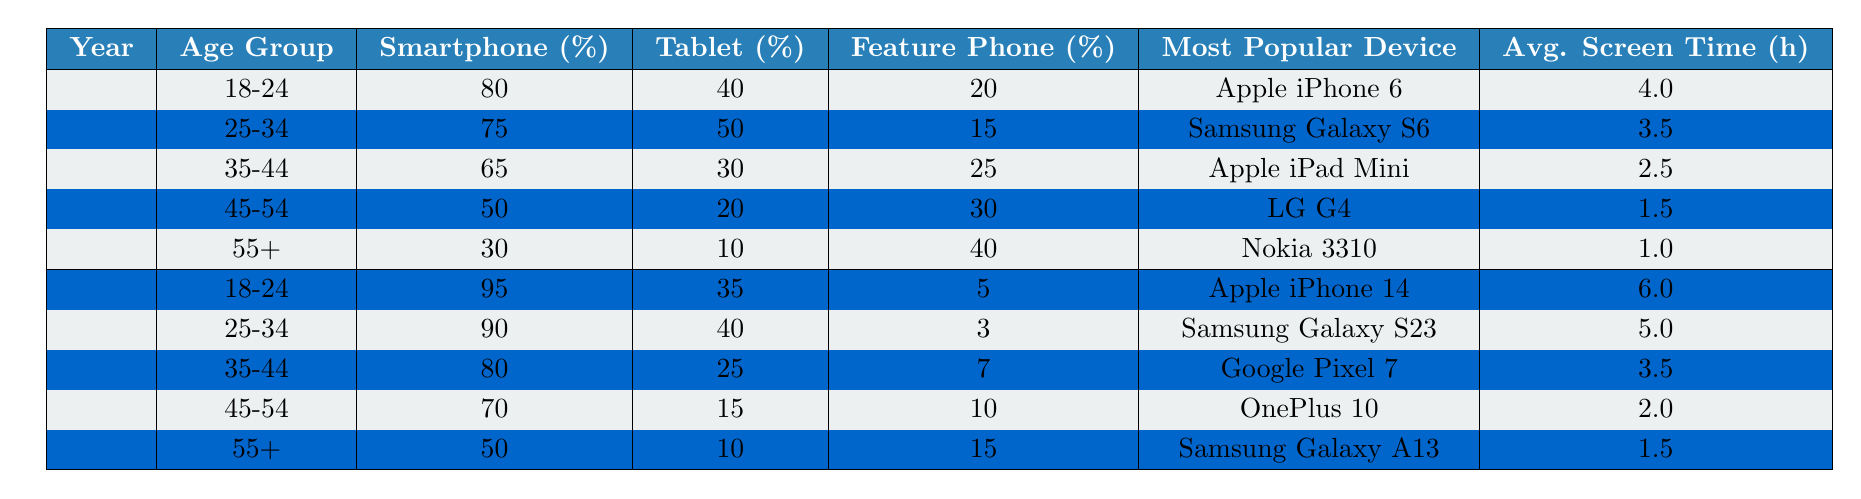What was the percentage of smartphone usage among the 25-34 age group in 2023? In the 2023 section of the table, under the 25-34 age group, the percentage of smartphone usage is listed as 90%.
Answer: 90% Which age group saw the highest average screen time in 2015? By looking at the average screen time values for each age group in 2015, the values are: 18-24 (4.0 hours), 25-34 (3.5 hours), 35-44 (2.5 hours), 45-54 (1.5 hours), and 55+ (1.0 hours). The highest is 4.0 hours for the 18-24 age group.
Answer: 18-24 Is it true that the percentage of feature phone usage decreased for the 18-24 age group from 2015 to 2023? In 2015, the percentage of feature phone usage for the 18-24 age group was 20%, and in 2023 it is 5%. Since 5% is less than 20%, the statement is true.
Answer: Yes What is the difference in the percentage of smartphone usage between the 45-54 age group in 2015 and 2023? The percentage of smartphone usage in 2015 for the 45-54 age group was 50%, and in 2023 it increased to 70%. The difference is 70% - 50% = 20%.
Answer: 20% Which popular device had the highest screen time increase over the years in the 18-24 age group? In 2015, the most popular device for the 18-24 age group was the Apple iPhone 6 with an average screen time of 4.0 hours. In 2023, it was the Apple iPhone 14 with 6.0 hours. The increase is 6.0 - 4.0 = 2.0 hours.
Answer: 2.0 hours In which age group was the Samsung Galaxy S23 the most popular device? Looking at the 2023 section, the most popular device for the 25-34 age group is the Samsung Galaxy S23.
Answer: 25-34 Which age group's percentage of tablet usage decreased from 2015 to 2023? By comparing the tablet usage percentages for each age group: 18-24 (40% to 35%), 25-34 (50% to 40%), 35-44 (30% to 25%), 45-54 (20% to 15%), and 55+ (10% to 10%). The 35-44 and 45-54 age groups both saw decreases, but the largest decrease was in 45-54.
Answer: 45-54 What is the average percentage of smartphone usage across all ages in 2023? The percentages of smartphone usage in 2023 for all age groups are: 95%, 90%, 80%, 70%, and 50%. Adding these gives a total of 95 + 90 + 80 + 70 + 50 = 385%. Dividing by 5 age groups gives an average of 385% / 5 = 77%.
Answer: 77% How did the most popular mobile device among the 35-44 age group change from 2015 to 2023? In 2015, the most popular device was the Apple iPad Mini, while in 2023 it changed to the Google Pixel 7.
Answer: Changed from Apple iPad Mini to Google Pixel 7 Which age group had the lowest percentage of smartphone usage in 2015? In 2015, the percentages of smartphone usage were: 18-24 (80%), 25-34 (75%), 35-44 (65%), 45-54 (50%), and 55+ (30%). The lowest percentage is 30% for the 55+ age group.
Answer: 55+ 